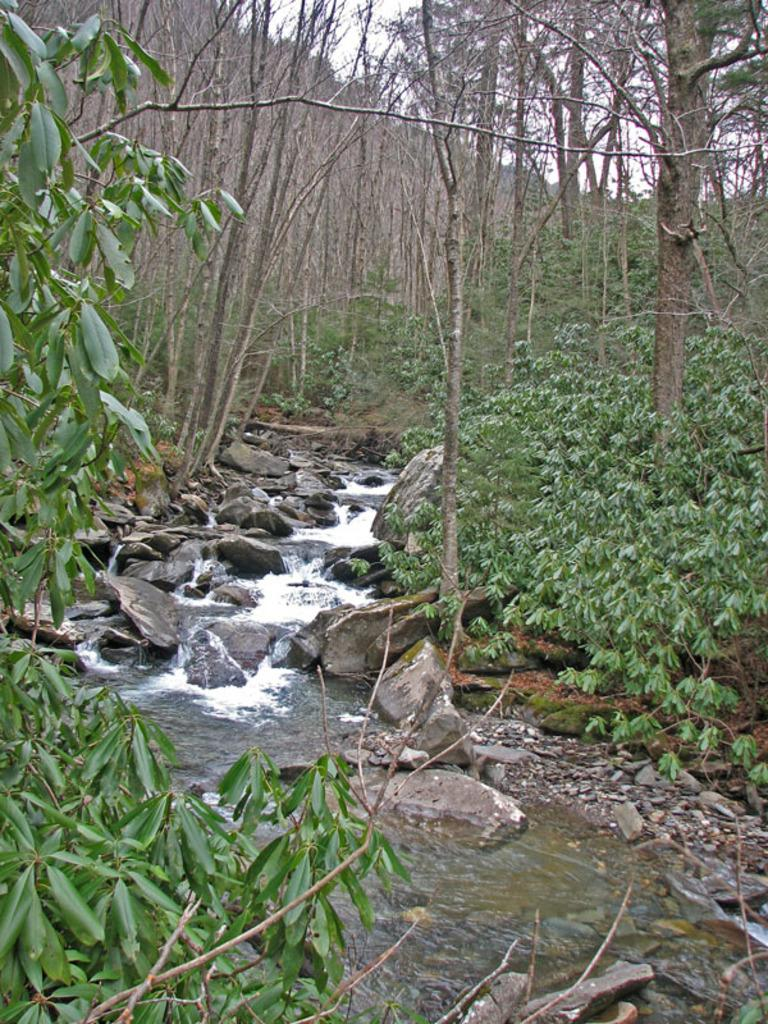What is at the bottom of the image? There is water at the bottom of the image. What can be found in the water? There are stones in the water. What is located in the middle of the image? There are trees in the middle of the image. What is visible behind the trees? The sky is visible behind the trees. How many steps can be seen leading up to the trees in the image? There are no steps visible in the image. What type of rabbits can be seen hopping around the trees in the image? There are no rabbits present in the image. 